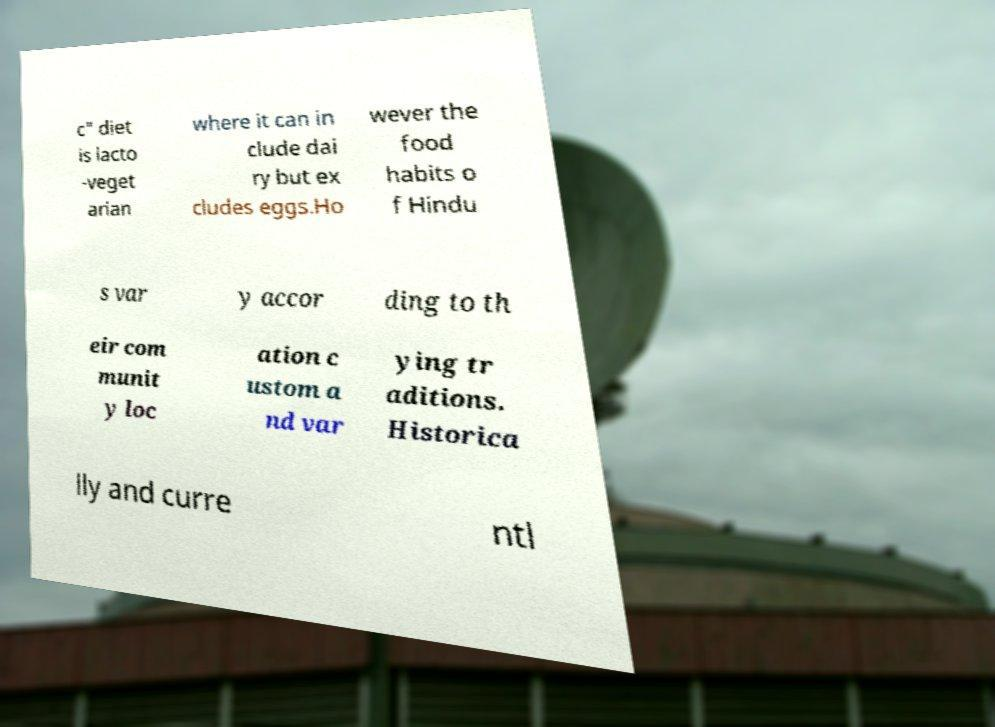Can you read and provide the text displayed in the image?This photo seems to have some interesting text. Can you extract and type it out for me? c" diet is lacto -veget arian where it can in clude dai ry but ex cludes eggs.Ho wever the food habits o f Hindu s var y accor ding to th eir com munit y loc ation c ustom a nd var ying tr aditions. Historica lly and curre ntl 